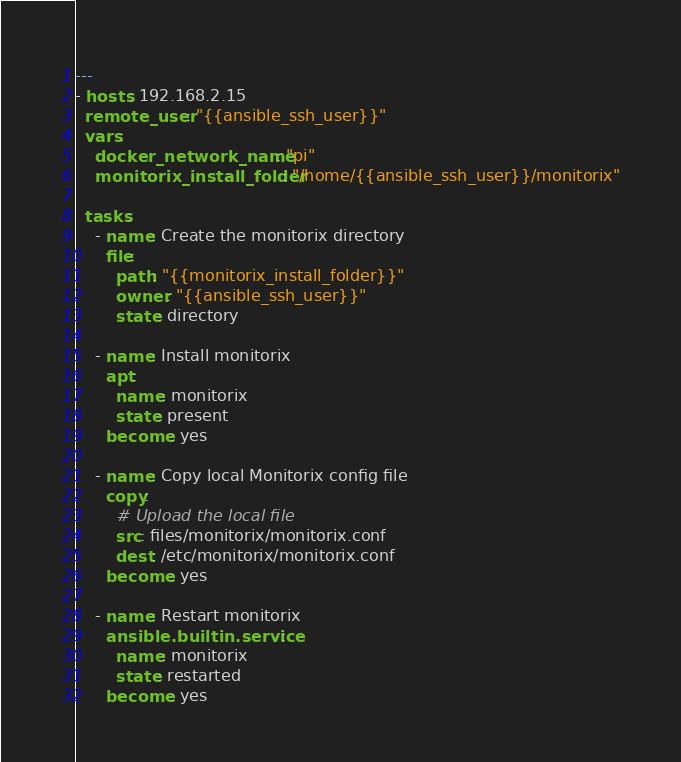Convert code to text. <code><loc_0><loc_0><loc_500><loc_500><_YAML_>---
- hosts: 192.168.2.15
  remote_user: "{{ansible_ssh_user}}"
  vars:
    docker_network_name: "pi"
    monitorix_install_folder: "/home/{{ansible_ssh_user}}/monitorix"

  tasks:
    - name: Create the monitorix directory
      file:
        path: "{{monitorix_install_folder}}"
        owner: "{{ansible_ssh_user}}"
        state: directory

    - name: Install monitorix
      apt:
        name: monitorix
        state: present
      become: yes

    - name: Copy local Monitorix config file
      copy:
        # Upload the local file
        src: files/monitorix/monitorix.conf
        dest: /etc/monitorix/monitorix.conf
      become: yes
    
    - name: Restart monitorix
      ansible.builtin.service:
        name: monitorix
        state: restarted
      become: yes</code> 